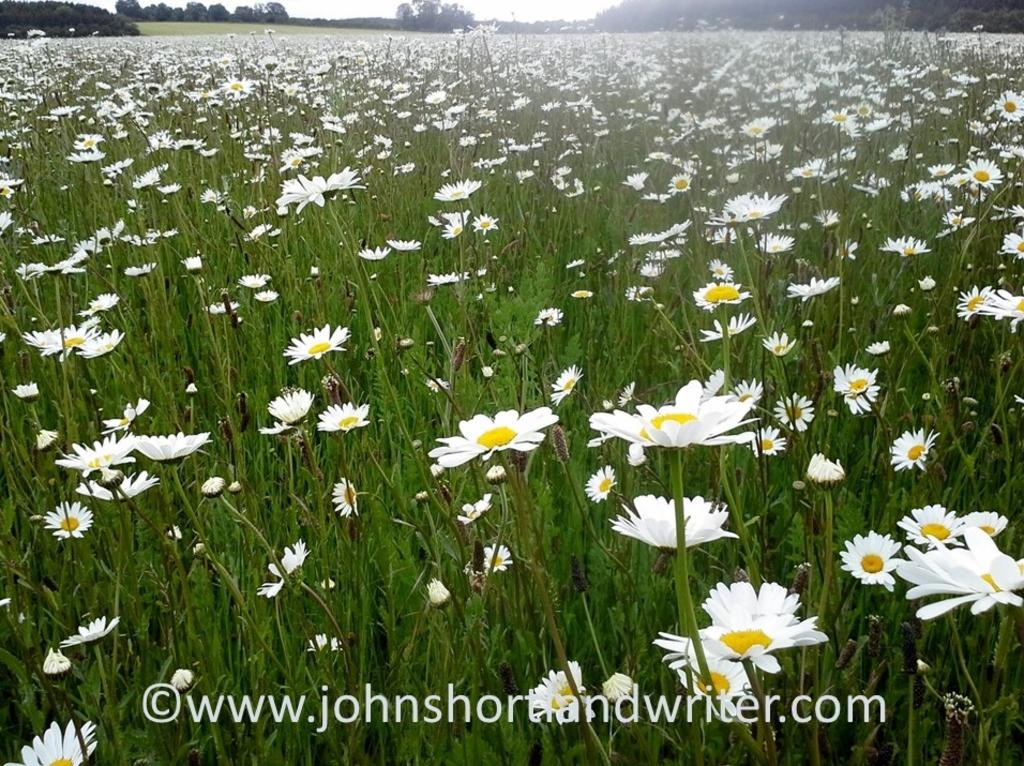What type of plants are present in the image? There are plants with white flowers in the image. What can be seen in the background of the image? There is grassland in the background of the image. Are there any trees visible in the grassland? Yes, there are trees in the grassland. What is visible at the top of the image? The sky is visible at the top of the image. How does the sneeze affect the plants in the image? There is no sneeze present in the image, so it cannot affect the plants. 